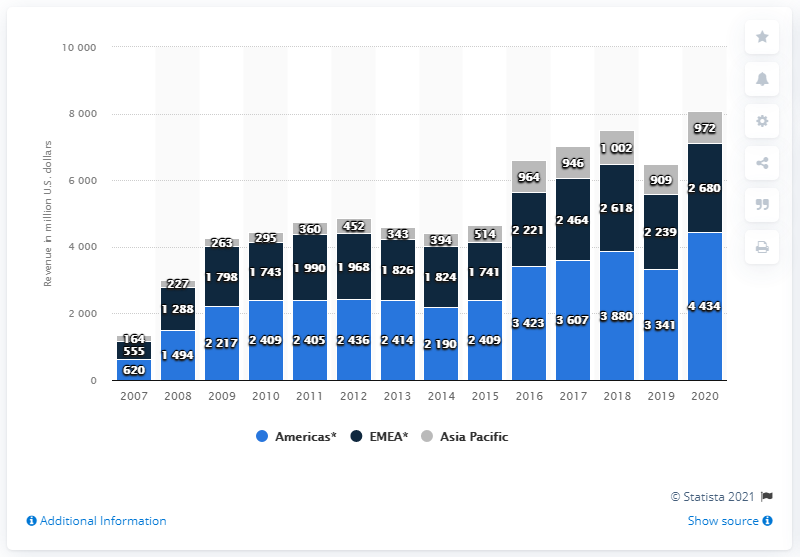List a handful of essential elements in this visual. In 2020, the EMEA (Europe, Middle East, and Africa) region generated approximately 2680 million in revenue. Activision Blizzard generated approximately $44,340 in revenue from the Americas region in 2020. 